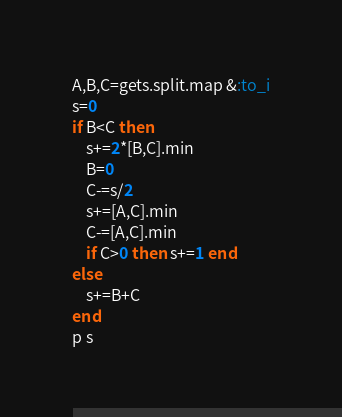Convert code to text. <code><loc_0><loc_0><loc_500><loc_500><_Ruby_>A,B,C=gets.split.map &:to_i
s=0
if B<C then
    s+=2*[B,C].min
    B=0
    C-=s/2
    s+=[A,C].min
    C-=[A,C].min
    if C>0 then s+=1 end
else
    s+=B+C
end
p s</code> 